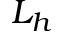Convert formula to latex. <formula><loc_0><loc_0><loc_500><loc_500>L _ { h }</formula> 